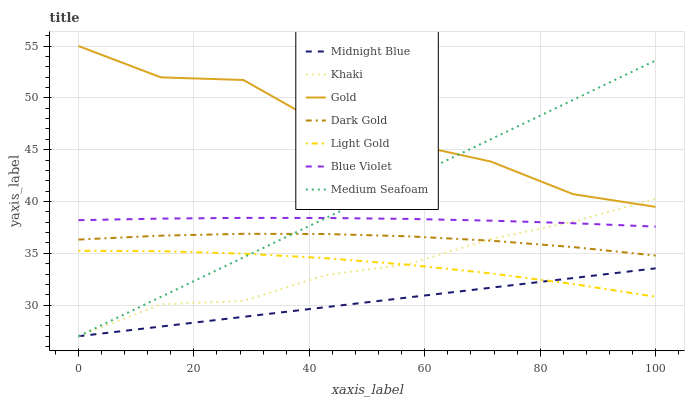Does Midnight Blue have the minimum area under the curve?
Answer yes or no. Yes. Does Gold have the maximum area under the curve?
Answer yes or no. Yes. Does Gold have the minimum area under the curve?
Answer yes or no. No. Does Midnight Blue have the maximum area under the curve?
Answer yes or no. No. Is Midnight Blue the smoothest?
Answer yes or no. Yes. Is Gold the roughest?
Answer yes or no. Yes. Is Gold the smoothest?
Answer yes or no. No. Is Midnight Blue the roughest?
Answer yes or no. No. Does Khaki have the lowest value?
Answer yes or no. Yes. Does Gold have the lowest value?
Answer yes or no. No. Does Gold have the highest value?
Answer yes or no. Yes. Does Midnight Blue have the highest value?
Answer yes or no. No. Is Light Gold less than Blue Violet?
Answer yes or no. Yes. Is Gold greater than Blue Violet?
Answer yes or no. Yes. Does Light Gold intersect Midnight Blue?
Answer yes or no. Yes. Is Light Gold less than Midnight Blue?
Answer yes or no. No. Is Light Gold greater than Midnight Blue?
Answer yes or no. No. Does Light Gold intersect Blue Violet?
Answer yes or no. No. 